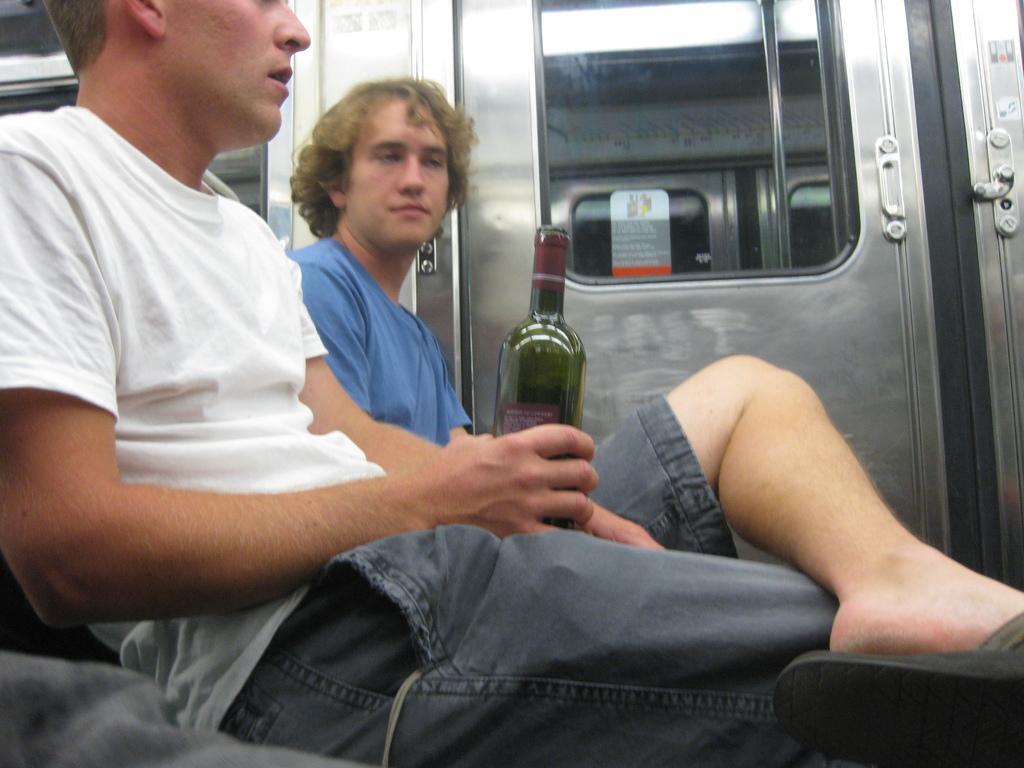How would you summarize this image in a sentence or two? This image is clicked inside a train where there is a door in the middle of the image and there are two persons sitting in the train. One person is wearing white T-shirt and black shirt with black chappal another one is wearing blue t-shirt. 